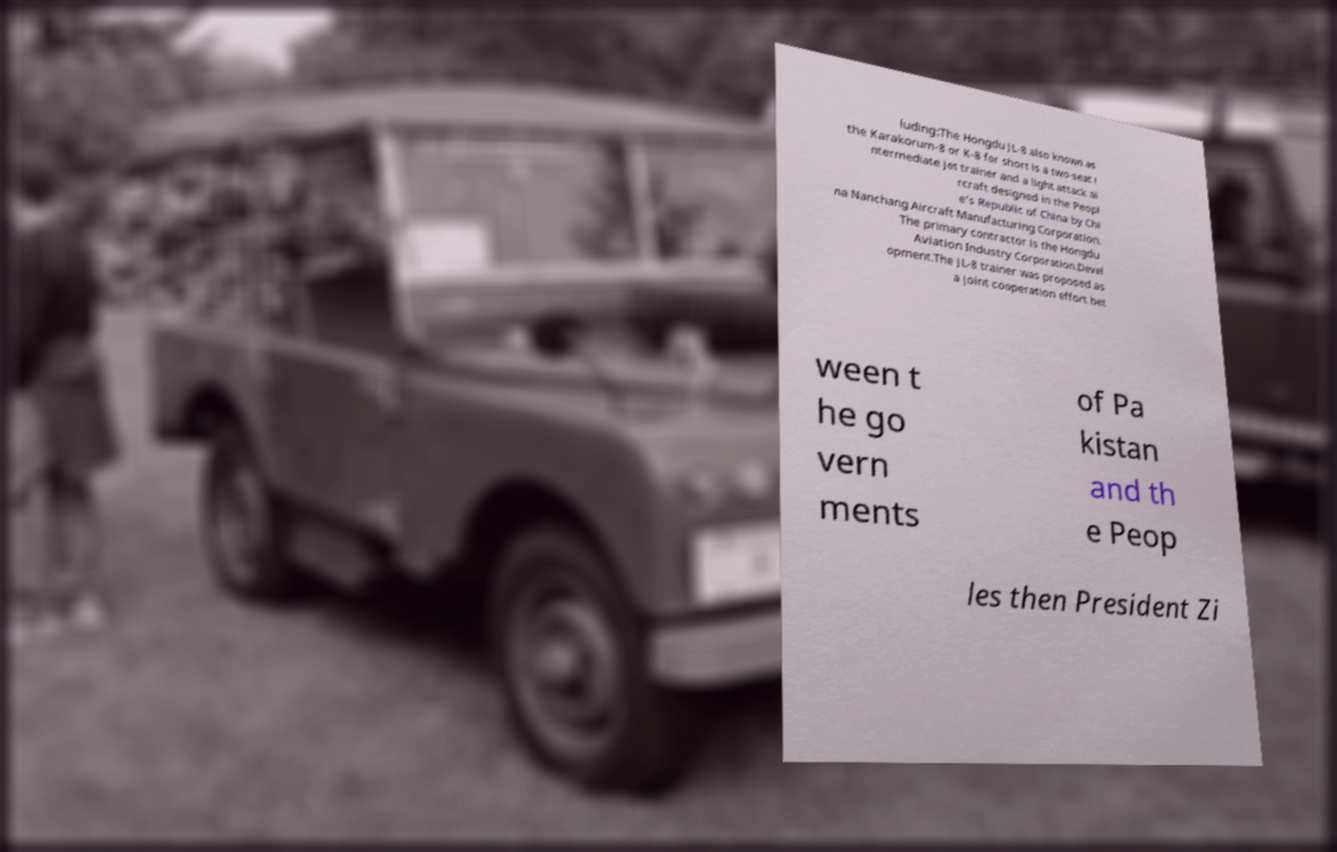Please read and relay the text visible in this image. What does it say? luding:The Hongdu JL-8 also known as the Karakorum-8 or K-8 for short is a two-seat i ntermediate jet trainer and a light attack ai rcraft designed in the Peopl e's Republic of China by Chi na Nanchang Aircraft Manufacturing Corporation. The primary contractor is the Hongdu Aviation Industry Corporation.Devel opment.The JL-8 trainer was proposed as a joint cooperation effort bet ween t he go vern ments of Pa kistan and th e Peop les then President Zi 